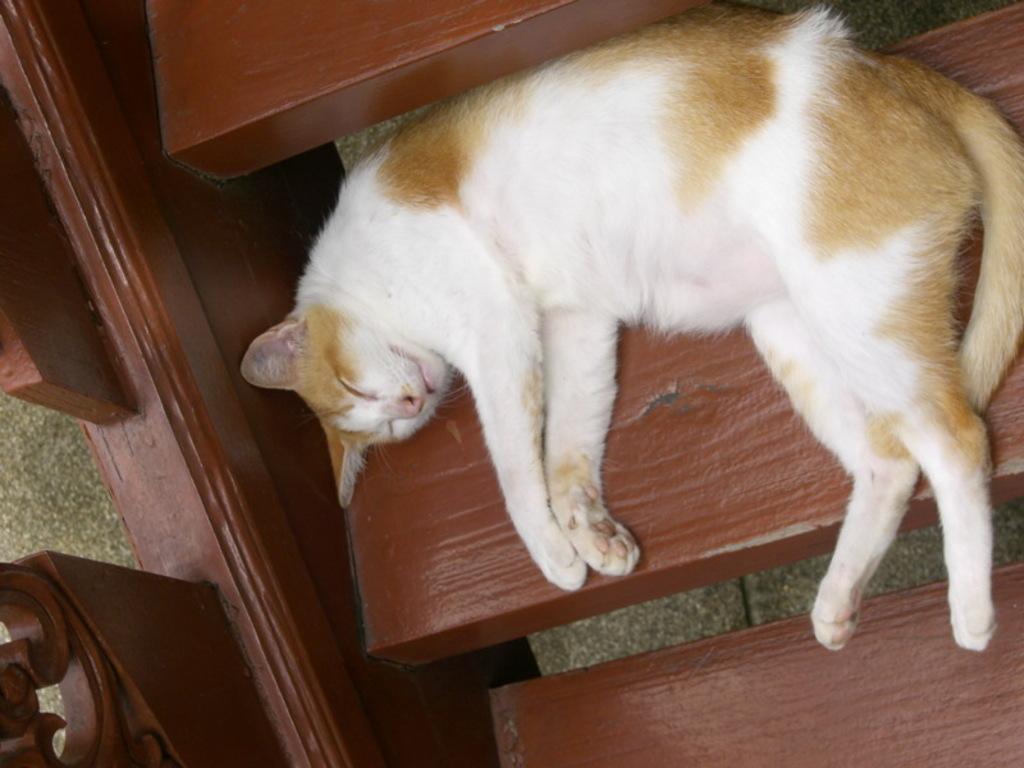How would you summarize this image in a sentence or two? In the center of the image a cat is present on the stairs. In the middle of the image floor is there. 